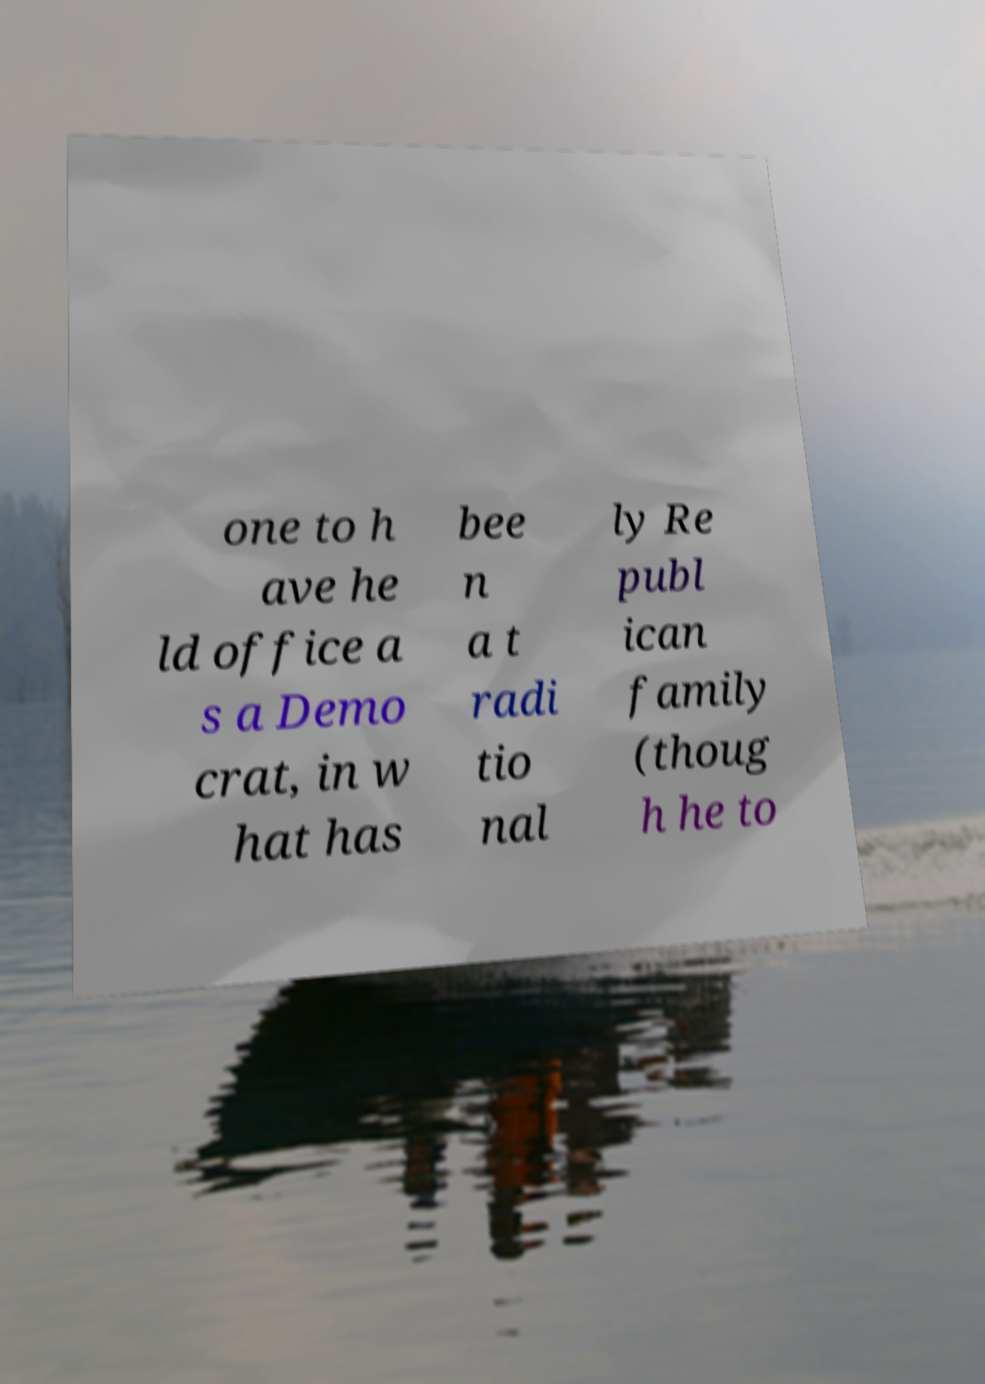Could you extract and type out the text from this image? one to h ave he ld office a s a Demo crat, in w hat has bee n a t radi tio nal ly Re publ ican family (thoug h he to 